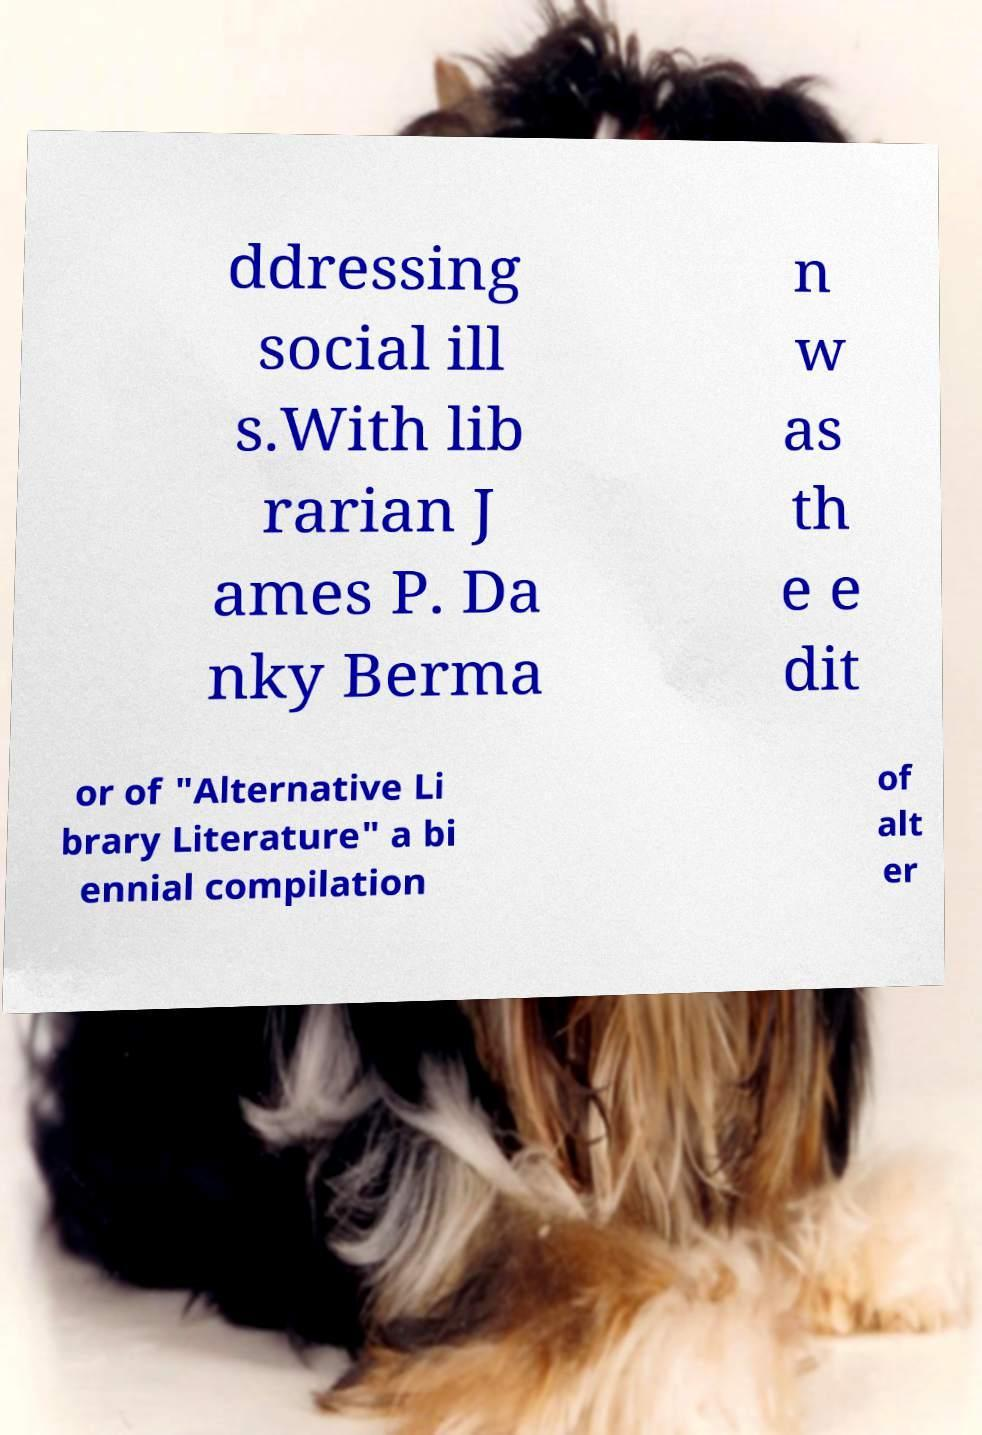Please identify and transcribe the text found in this image. ddressing social ill s.With lib rarian J ames P. Da nky Berma n w as th e e dit or of "Alternative Li brary Literature" a bi ennial compilation of alt er 